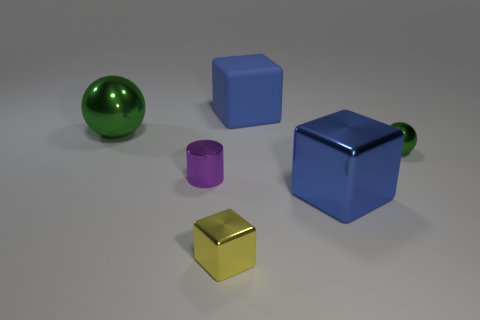Add 2 large blue objects. How many objects exist? 8 Subtract all spheres. How many objects are left? 4 Subtract all purple blocks. Subtract all small green things. How many objects are left? 5 Add 1 cubes. How many cubes are left? 4 Add 3 blue cubes. How many blue cubes exist? 5 Subtract 0 blue cylinders. How many objects are left? 6 